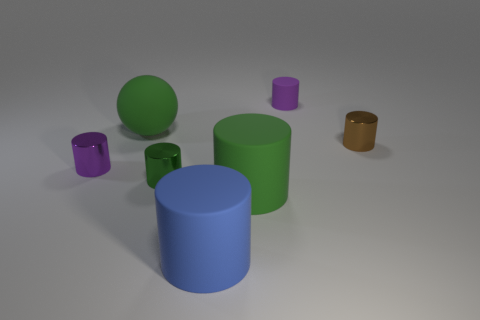What is the size of the green rubber object that is the same shape as the blue thing?
Your answer should be very brief. Large. Does the big sphere have the same color as the shiny cylinder in front of the purple metal thing?
Make the answer very short. Yes. What number of other things are the same size as the brown thing?
Give a very brief answer. 3. There is a brown shiny object; is it the same size as the green cylinder that is on the right side of the blue matte thing?
Give a very brief answer. No. There is a object left of the big ball; does it have the same color as the matte cylinder behind the small purple metal cylinder?
Ensure brevity in your answer.  Yes. How many small shiny cylinders are the same color as the rubber sphere?
Keep it short and to the point. 1. What size is the green cylinder that is the same material as the large blue object?
Keep it short and to the point. Large. Is the number of purple rubber objects that are right of the tiny matte cylinder greater than the number of metallic cylinders that are behind the tiny brown metallic object?
Offer a very short reply. No. What material is the brown cylinder?
Your response must be concise. Metal. Is there a purple cylinder that has the same size as the brown thing?
Keep it short and to the point. Yes. 